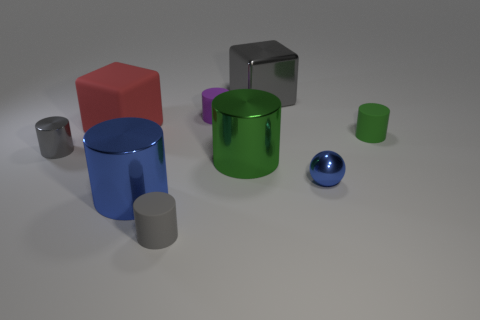What number of big red blocks are there?
Make the answer very short. 1. Do the cylinder right of the metallic block and the big blue cylinder have the same material?
Offer a very short reply. No. Are there any green rubber objects that have the same size as the purple matte object?
Make the answer very short. Yes. There is a large blue metal thing; is it the same shape as the tiny rubber object right of the small blue metal sphere?
Your answer should be compact. Yes. There is a green thing left of the big metallic thing that is behind the big green shiny object; is there a object behind it?
Your response must be concise. Yes. How big is the gray metal cylinder?
Provide a short and direct response. Small. How many other things are the same color as the large metallic block?
Keep it short and to the point. 2. There is a gray metallic object on the right side of the gray rubber object; is it the same shape as the big blue object?
Your answer should be very brief. No. What is the color of the tiny metal thing that is the same shape as the green rubber thing?
Provide a succinct answer. Gray. Is there any other thing that is the same material as the large red cube?
Your answer should be compact. Yes. 